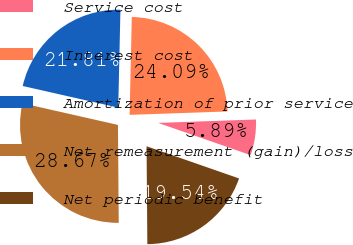Convert chart to OTSL. <chart><loc_0><loc_0><loc_500><loc_500><pie_chart><fcel>Service cost<fcel>Interest cost<fcel>Amortization of prior service<fcel>Net remeasurement (gain)/loss<fcel>Net periodic benefit<nl><fcel>5.89%<fcel>24.09%<fcel>21.81%<fcel>28.67%<fcel>19.54%<nl></chart> 